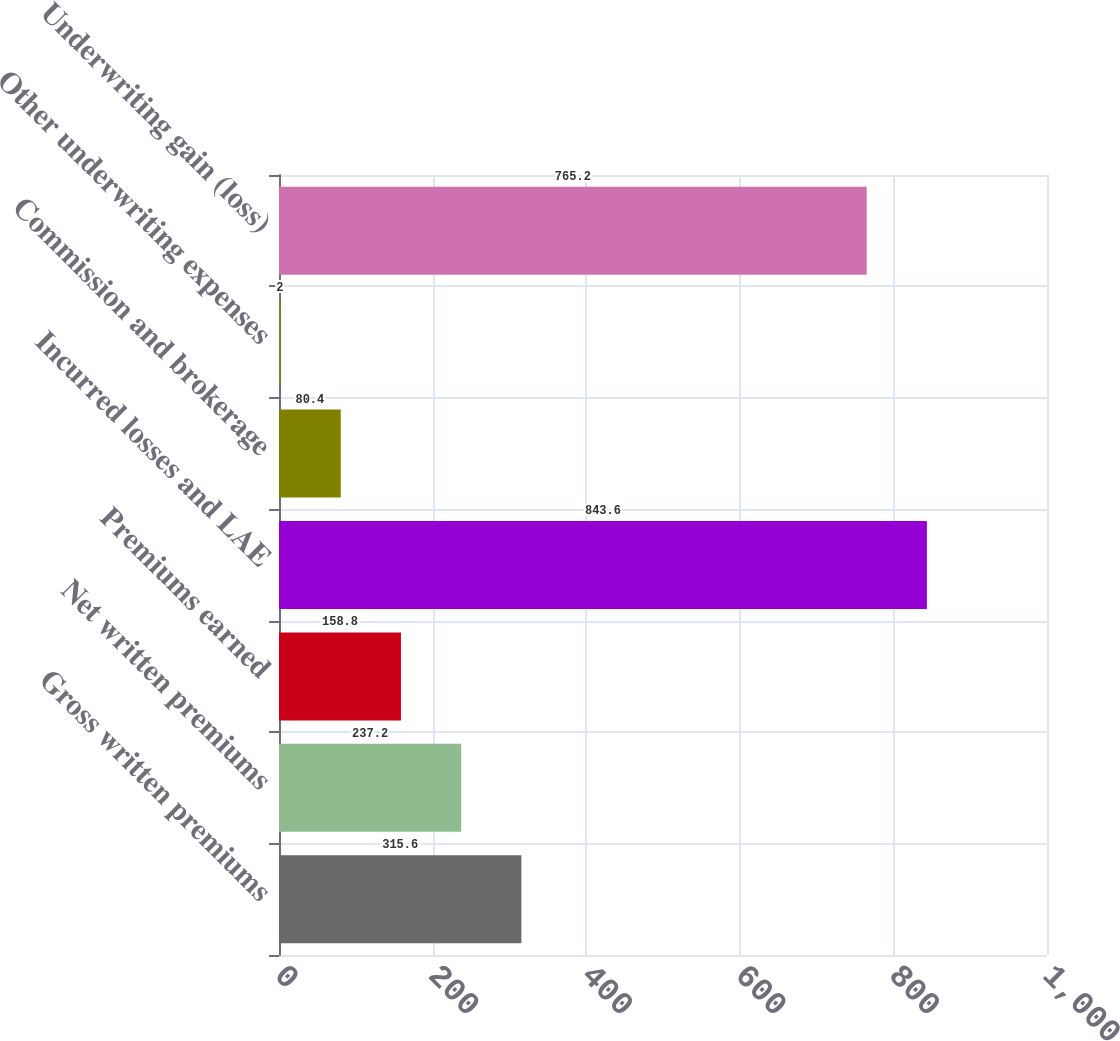Convert chart. <chart><loc_0><loc_0><loc_500><loc_500><bar_chart><fcel>Gross written premiums<fcel>Net written premiums<fcel>Premiums earned<fcel>Incurred losses and LAE<fcel>Commission and brokerage<fcel>Other underwriting expenses<fcel>Underwriting gain (loss)<nl><fcel>315.6<fcel>237.2<fcel>158.8<fcel>843.6<fcel>80.4<fcel>2<fcel>765.2<nl></chart> 